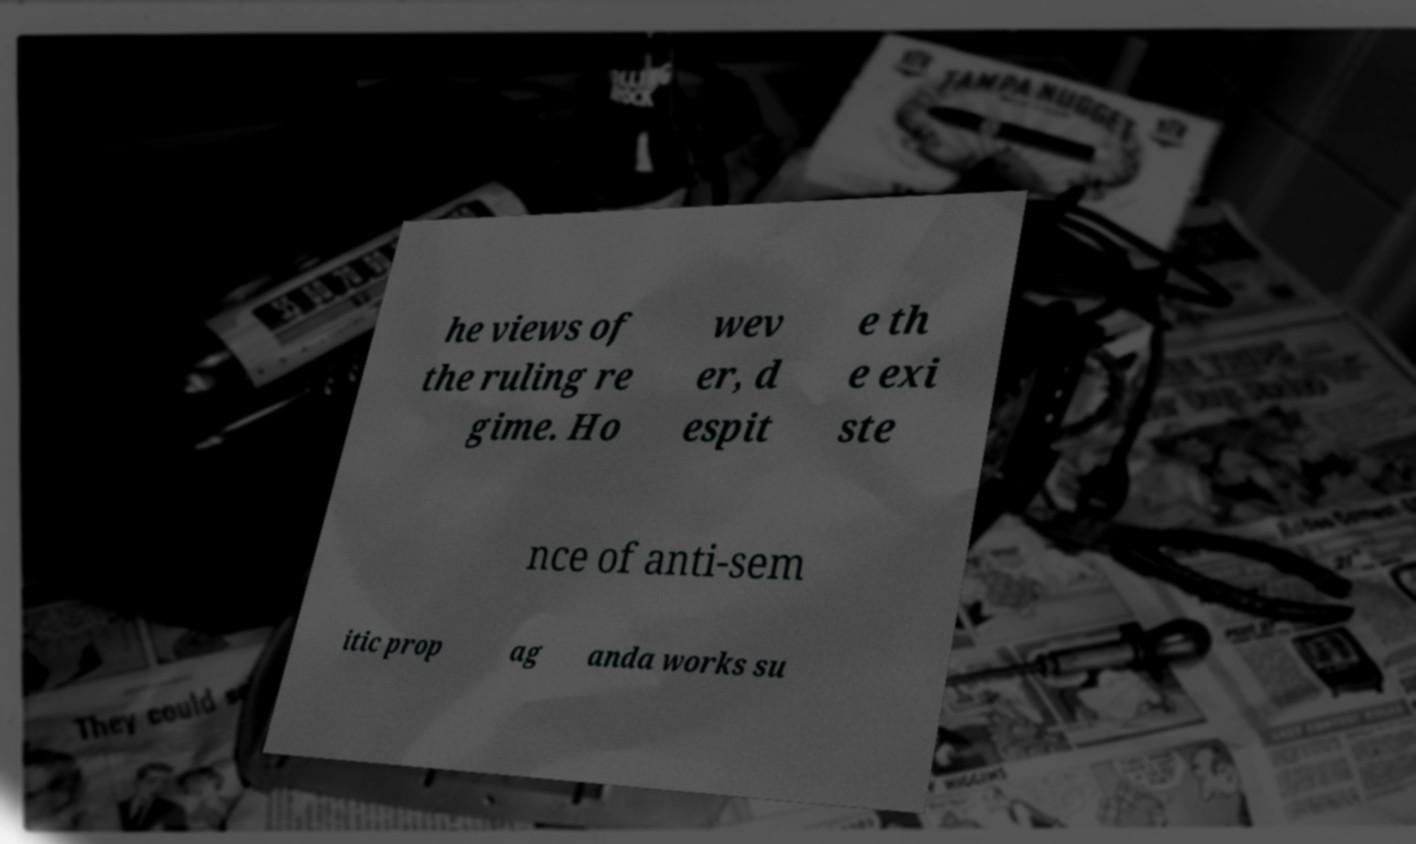Could you assist in decoding the text presented in this image and type it out clearly? he views of the ruling re gime. Ho wev er, d espit e th e exi ste nce of anti-sem itic prop ag anda works su 